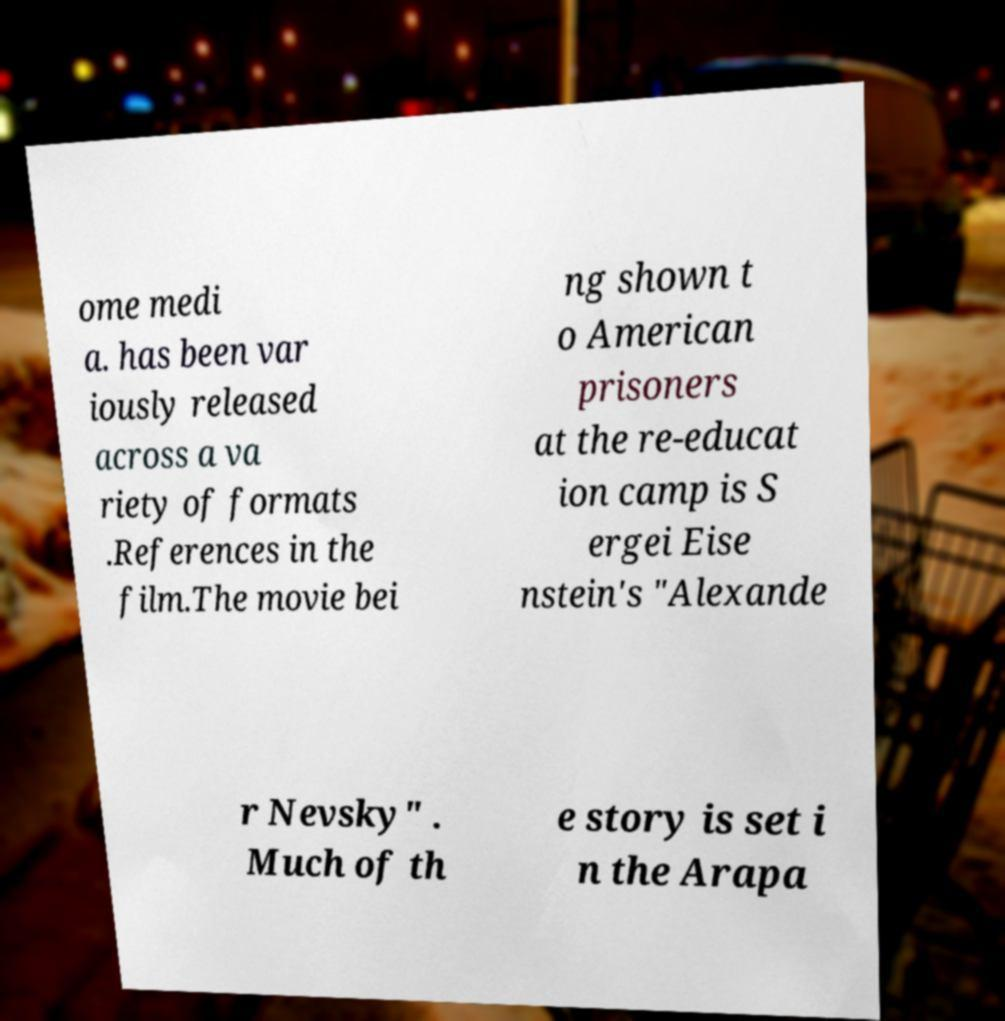There's text embedded in this image that I need extracted. Can you transcribe it verbatim? ome medi a. has been var iously released across a va riety of formats .References in the film.The movie bei ng shown t o American prisoners at the re-educat ion camp is S ergei Eise nstein's "Alexande r Nevsky" . Much of th e story is set i n the Arapa 